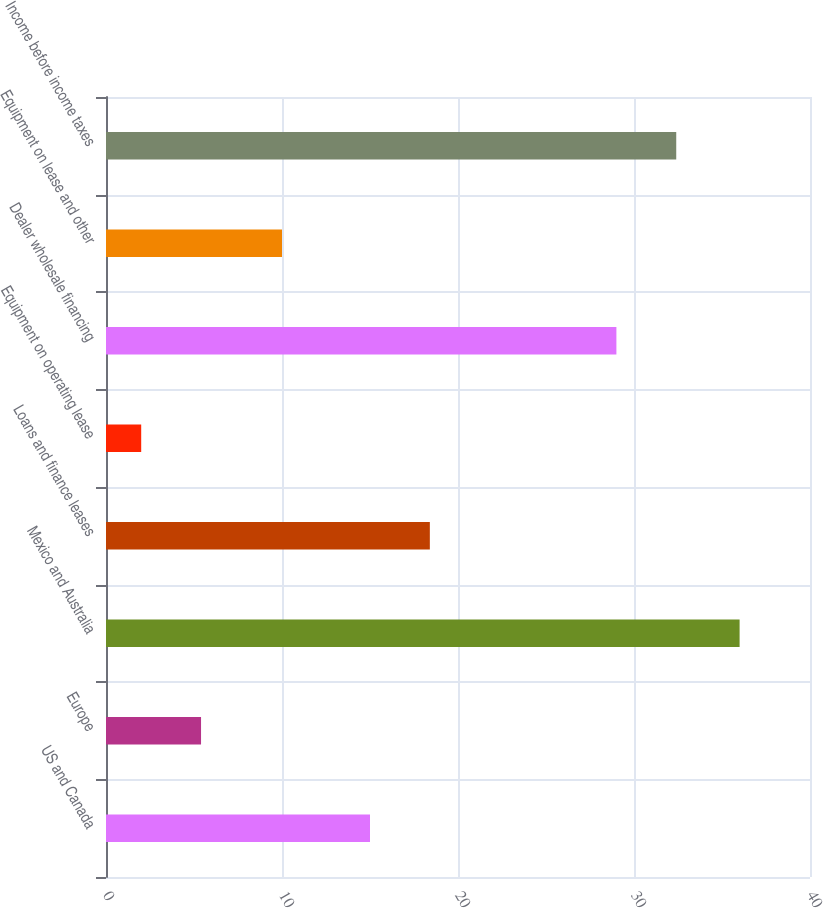<chart> <loc_0><loc_0><loc_500><loc_500><bar_chart><fcel>US and Canada<fcel>Europe<fcel>Mexico and Australia<fcel>Loans and finance leases<fcel>Equipment on operating lease<fcel>Dealer wholesale financing<fcel>Equipment on lease and other<fcel>Income before income taxes<nl><fcel>15<fcel>5.4<fcel>36<fcel>18.4<fcel>2<fcel>29<fcel>10<fcel>32.4<nl></chart> 